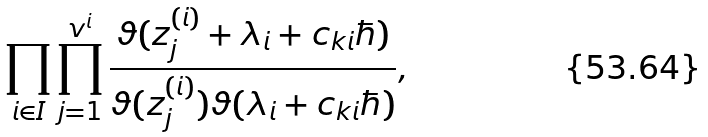Convert formula to latex. <formula><loc_0><loc_0><loc_500><loc_500>\prod _ { i \in I } \prod _ { j = 1 } ^ { v ^ { i } } \frac { \vartheta ( z ^ { ( i ) } _ { j } + \lambda _ { i } + c _ { k i } \hbar { ) } } { \vartheta ( z ^ { ( i ) } _ { j } ) \vartheta ( \lambda _ { i } + c _ { k i } \hbar { ) } } ,</formula> 